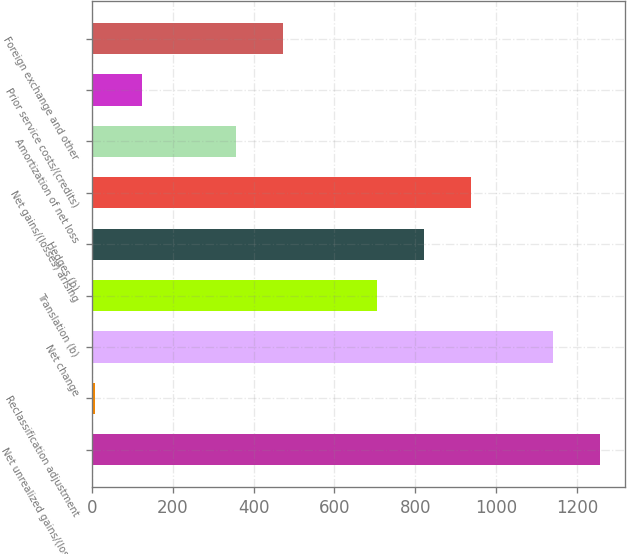Convert chart to OTSL. <chart><loc_0><loc_0><loc_500><loc_500><bar_chart><fcel>Net unrealized gains/(losses)<fcel>Reclassification adjustment<fcel>Net change<fcel>Translation (b)<fcel>Hedges (b)<fcel>Net gains/(losses) arising<fcel>Amortization of net loss<fcel>Prior service costs/(credits)<fcel>Foreign exchange and other<nl><fcel>1257.1<fcel>9<fcel>1141<fcel>705.6<fcel>821.7<fcel>937.8<fcel>357.3<fcel>125.1<fcel>473.4<nl></chart> 